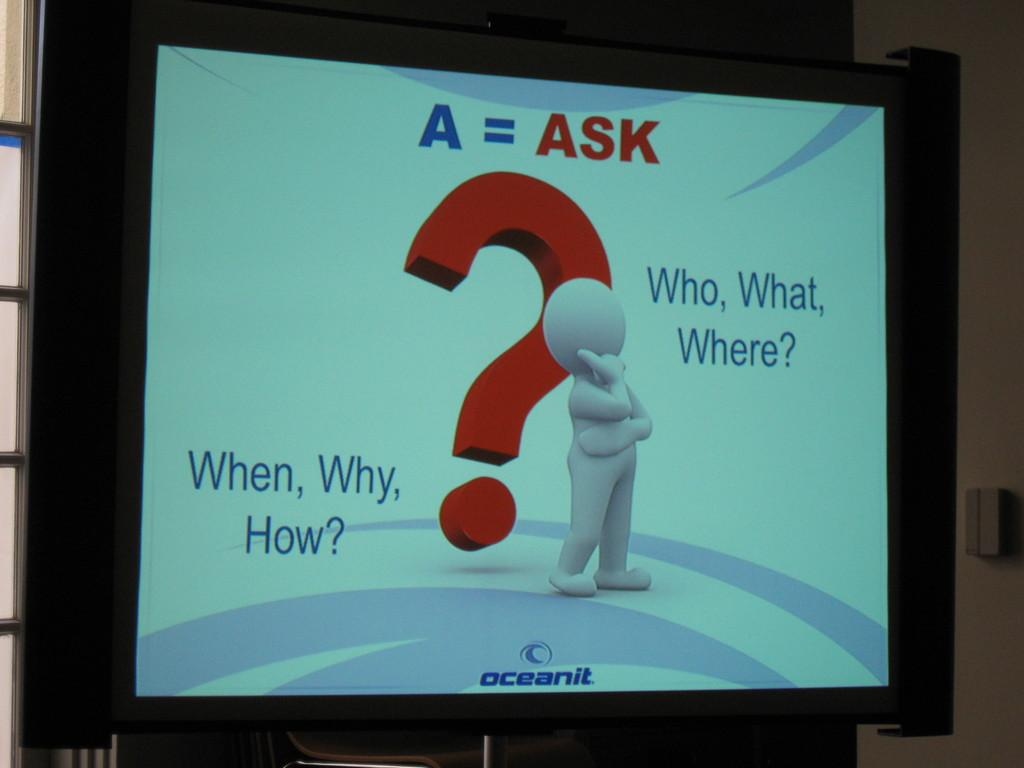Provide a one-sentence caption for the provided image. A monitor screen shows a number of questions relating to the company OceanIT. 